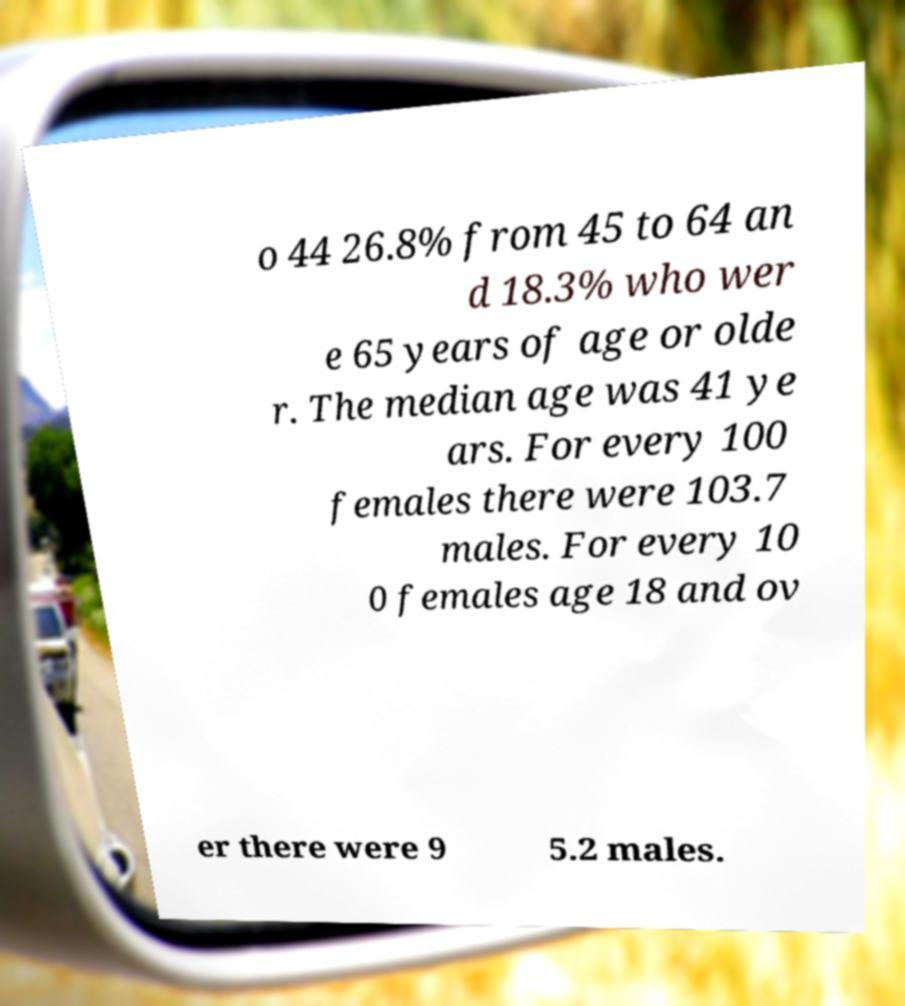Can you read and provide the text displayed in the image?This photo seems to have some interesting text. Can you extract and type it out for me? o 44 26.8% from 45 to 64 an d 18.3% who wer e 65 years of age or olde r. The median age was 41 ye ars. For every 100 females there were 103.7 males. For every 10 0 females age 18 and ov er there were 9 5.2 males. 